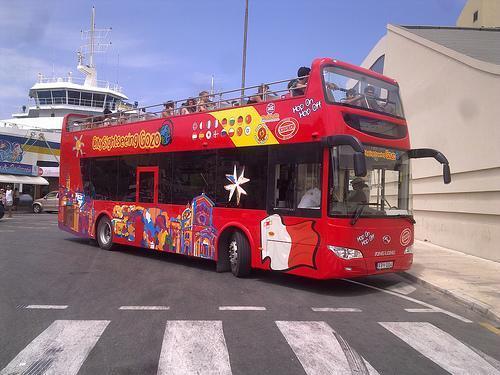How many decks are on the bus?
Give a very brief answer. 2. How many doors can be seen on the bus?
Give a very brief answer. 1. 